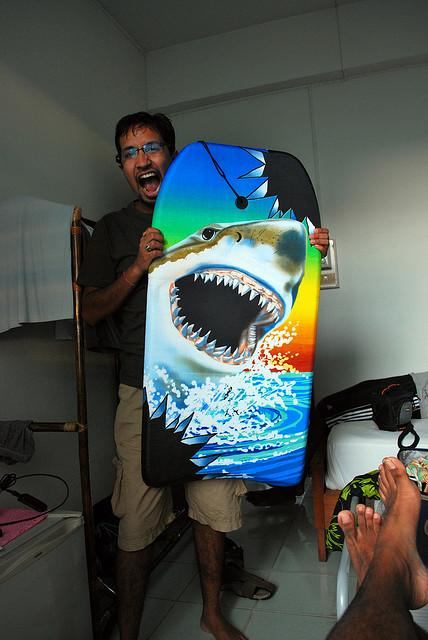What water sport is the object the man is holding used in? Please explain your reasoning. bodyboarding. The man is holding a body board that is used instead of a surfboard in the ocean. 